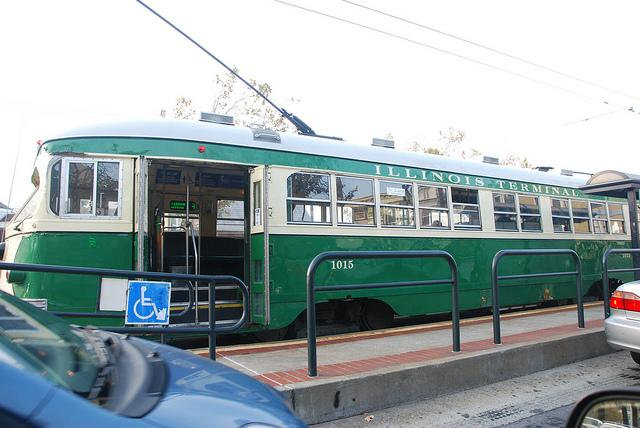What is available according to the blue sign? handicap seats 